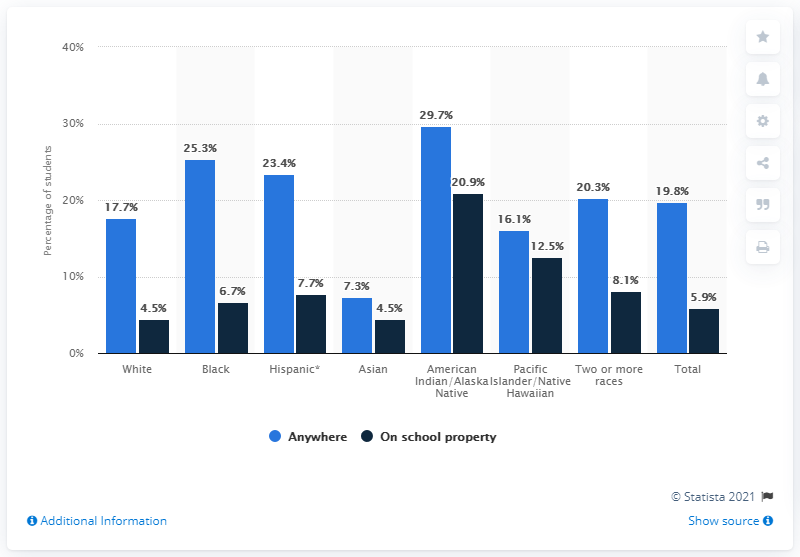Draw attention to some important aspects in this diagram. According to a survey conducted in 2017, 7.3% of Asian students reported having smoked marijuana at some point in their lifetime. 